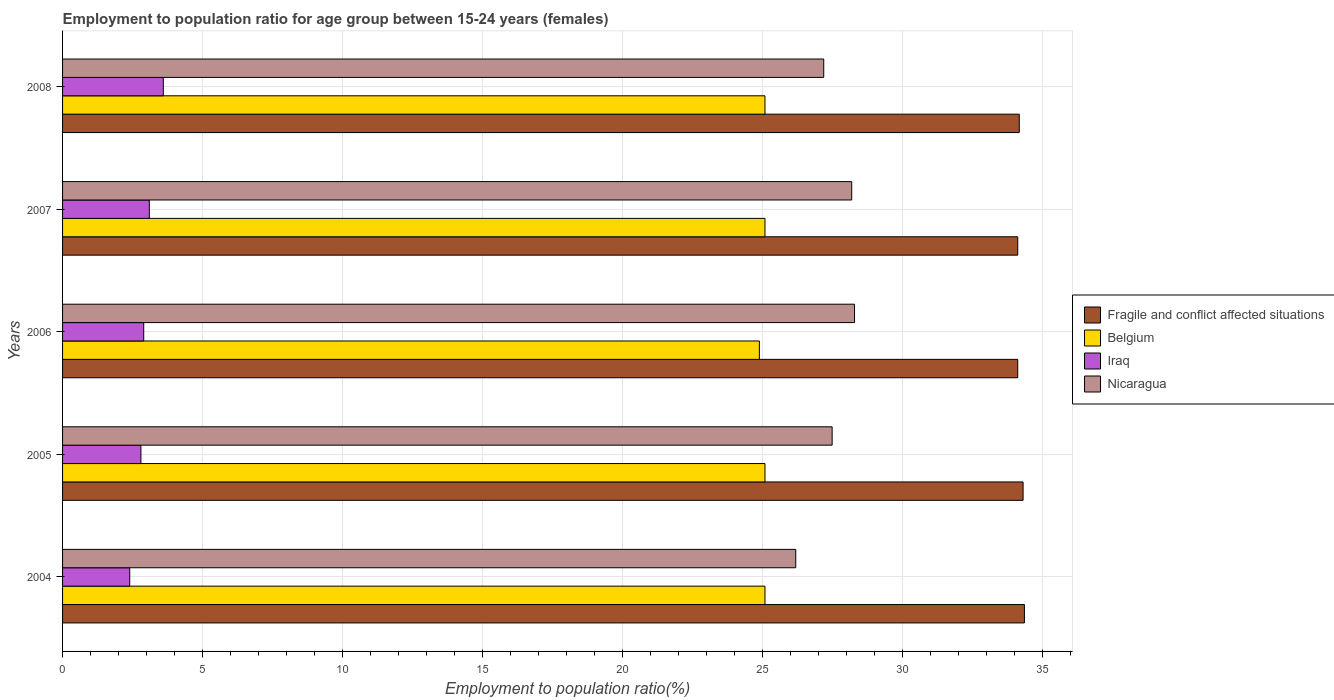Are the number of bars on each tick of the Y-axis equal?
Your answer should be very brief. Yes. How many bars are there on the 1st tick from the bottom?
Provide a short and direct response. 4. What is the label of the 1st group of bars from the top?
Provide a succinct answer. 2008. In how many cases, is the number of bars for a given year not equal to the number of legend labels?
Give a very brief answer. 0. What is the employment to population ratio in Iraq in 2007?
Ensure brevity in your answer.  3.1. Across all years, what is the maximum employment to population ratio in Nicaragua?
Your response must be concise. 28.3. Across all years, what is the minimum employment to population ratio in Belgium?
Provide a short and direct response. 24.9. In which year was the employment to population ratio in Iraq maximum?
Your answer should be very brief. 2008. What is the total employment to population ratio in Fragile and conflict affected situations in the graph?
Keep it short and to the point. 171.15. What is the difference between the employment to population ratio in Fragile and conflict affected situations in 2006 and the employment to population ratio in Iraq in 2005?
Your answer should be very brief. 31.33. What is the average employment to population ratio in Fragile and conflict affected situations per year?
Make the answer very short. 34.23. In the year 2008, what is the difference between the employment to population ratio in Belgium and employment to population ratio in Nicaragua?
Provide a short and direct response. -2.1. Is the employment to population ratio in Fragile and conflict affected situations in 2004 less than that in 2005?
Your answer should be very brief. No. What is the difference between the highest and the second highest employment to population ratio in Nicaragua?
Offer a very short reply. 0.1. What is the difference between the highest and the lowest employment to population ratio in Fragile and conflict affected situations?
Your answer should be very brief. 0.24. What does the 3rd bar from the bottom in 2006 represents?
Make the answer very short. Iraq. Are all the bars in the graph horizontal?
Ensure brevity in your answer.  Yes. What is the difference between two consecutive major ticks on the X-axis?
Offer a very short reply. 5. Are the values on the major ticks of X-axis written in scientific E-notation?
Ensure brevity in your answer.  No. How are the legend labels stacked?
Give a very brief answer. Vertical. What is the title of the graph?
Your response must be concise. Employment to population ratio for age group between 15-24 years (females). Does "Lesotho" appear as one of the legend labels in the graph?
Your response must be concise. No. What is the label or title of the X-axis?
Offer a terse response. Employment to population ratio(%). What is the Employment to population ratio(%) in Fragile and conflict affected situations in 2004?
Ensure brevity in your answer.  34.37. What is the Employment to population ratio(%) of Belgium in 2004?
Make the answer very short. 25.1. What is the Employment to population ratio(%) of Iraq in 2004?
Provide a short and direct response. 2.4. What is the Employment to population ratio(%) of Nicaragua in 2004?
Provide a succinct answer. 26.2. What is the Employment to population ratio(%) of Fragile and conflict affected situations in 2005?
Give a very brief answer. 34.32. What is the Employment to population ratio(%) in Belgium in 2005?
Ensure brevity in your answer.  25.1. What is the Employment to population ratio(%) in Iraq in 2005?
Keep it short and to the point. 2.8. What is the Employment to population ratio(%) of Nicaragua in 2005?
Ensure brevity in your answer.  27.5. What is the Employment to population ratio(%) of Fragile and conflict affected situations in 2006?
Keep it short and to the point. 34.13. What is the Employment to population ratio(%) of Belgium in 2006?
Offer a very short reply. 24.9. What is the Employment to population ratio(%) in Iraq in 2006?
Give a very brief answer. 2.9. What is the Employment to population ratio(%) of Nicaragua in 2006?
Provide a succinct answer. 28.3. What is the Employment to population ratio(%) of Fragile and conflict affected situations in 2007?
Provide a short and direct response. 34.13. What is the Employment to population ratio(%) of Belgium in 2007?
Give a very brief answer. 25.1. What is the Employment to population ratio(%) in Iraq in 2007?
Ensure brevity in your answer.  3.1. What is the Employment to population ratio(%) of Nicaragua in 2007?
Your answer should be very brief. 28.2. What is the Employment to population ratio(%) in Fragile and conflict affected situations in 2008?
Make the answer very short. 34.19. What is the Employment to population ratio(%) in Belgium in 2008?
Offer a very short reply. 25.1. What is the Employment to population ratio(%) of Iraq in 2008?
Give a very brief answer. 3.6. What is the Employment to population ratio(%) in Nicaragua in 2008?
Your answer should be compact. 27.2. Across all years, what is the maximum Employment to population ratio(%) in Fragile and conflict affected situations?
Give a very brief answer. 34.37. Across all years, what is the maximum Employment to population ratio(%) of Belgium?
Provide a short and direct response. 25.1. Across all years, what is the maximum Employment to population ratio(%) in Iraq?
Provide a succinct answer. 3.6. Across all years, what is the maximum Employment to population ratio(%) in Nicaragua?
Provide a succinct answer. 28.3. Across all years, what is the minimum Employment to population ratio(%) of Fragile and conflict affected situations?
Keep it short and to the point. 34.13. Across all years, what is the minimum Employment to population ratio(%) in Belgium?
Your response must be concise. 24.9. Across all years, what is the minimum Employment to population ratio(%) in Iraq?
Your answer should be compact. 2.4. Across all years, what is the minimum Employment to population ratio(%) of Nicaragua?
Your response must be concise. 26.2. What is the total Employment to population ratio(%) in Fragile and conflict affected situations in the graph?
Offer a terse response. 171.15. What is the total Employment to population ratio(%) of Belgium in the graph?
Offer a very short reply. 125.3. What is the total Employment to population ratio(%) in Iraq in the graph?
Offer a very short reply. 14.8. What is the total Employment to population ratio(%) in Nicaragua in the graph?
Offer a very short reply. 137.4. What is the difference between the Employment to population ratio(%) of Fragile and conflict affected situations in 2004 and that in 2005?
Offer a terse response. 0.05. What is the difference between the Employment to population ratio(%) of Iraq in 2004 and that in 2005?
Your answer should be compact. -0.4. What is the difference between the Employment to population ratio(%) in Fragile and conflict affected situations in 2004 and that in 2006?
Give a very brief answer. 0.24. What is the difference between the Employment to population ratio(%) in Iraq in 2004 and that in 2006?
Offer a very short reply. -0.5. What is the difference between the Employment to population ratio(%) in Nicaragua in 2004 and that in 2006?
Your response must be concise. -2.1. What is the difference between the Employment to population ratio(%) in Fragile and conflict affected situations in 2004 and that in 2007?
Keep it short and to the point. 0.24. What is the difference between the Employment to population ratio(%) in Nicaragua in 2004 and that in 2007?
Keep it short and to the point. -2. What is the difference between the Employment to population ratio(%) of Fragile and conflict affected situations in 2004 and that in 2008?
Offer a terse response. 0.18. What is the difference between the Employment to population ratio(%) of Belgium in 2004 and that in 2008?
Offer a very short reply. 0. What is the difference between the Employment to population ratio(%) in Iraq in 2004 and that in 2008?
Ensure brevity in your answer.  -1.2. What is the difference between the Employment to population ratio(%) of Fragile and conflict affected situations in 2005 and that in 2006?
Ensure brevity in your answer.  0.19. What is the difference between the Employment to population ratio(%) of Iraq in 2005 and that in 2006?
Your answer should be very brief. -0.1. What is the difference between the Employment to population ratio(%) in Fragile and conflict affected situations in 2005 and that in 2007?
Your response must be concise. 0.19. What is the difference between the Employment to population ratio(%) in Iraq in 2005 and that in 2007?
Provide a short and direct response. -0.3. What is the difference between the Employment to population ratio(%) in Fragile and conflict affected situations in 2005 and that in 2008?
Ensure brevity in your answer.  0.14. What is the difference between the Employment to population ratio(%) in Iraq in 2005 and that in 2008?
Offer a terse response. -0.8. What is the difference between the Employment to population ratio(%) in Nicaragua in 2005 and that in 2008?
Keep it short and to the point. 0.3. What is the difference between the Employment to population ratio(%) of Fragile and conflict affected situations in 2006 and that in 2007?
Make the answer very short. -0. What is the difference between the Employment to population ratio(%) of Fragile and conflict affected situations in 2006 and that in 2008?
Keep it short and to the point. -0.05. What is the difference between the Employment to population ratio(%) in Iraq in 2006 and that in 2008?
Offer a terse response. -0.7. What is the difference between the Employment to population ratio(%) in Nicaragua in 2006 and that in 2008?
Give a very brief answer. 1.1. What is the difference between the Employment to population ratio(%) of Fragile and conflict affected situations in 2007 and that in 2008?
Give a very brief answer. -0.05. What is the difference between the Employment to population ratio(%) in Belgium in 2007 and that in 2008?
Provide a succinct answer. 0. What is the difference between the Employment to population ratio(%) in Iraq in 2007 and that in 2008?
Offer a very short reply. -0.5. What is the difference between the Employment to population ratio(%) of Nicaragua in 2007 and that in 2008?
Your answer should be compact. 1. What is the difference between the Employment to population ratio(%) of Fragile and conflict affected situations in 2004 and the Employment to population ratio(%) of Belgium in 2005?
Provide a succinct answer. 9.27. What is the difference between the Employment to population ratio(%) of Fragile and conflict affected situations in 2004 and the Employment to population ratio(%) of Iraq in 2005?
Give a very brief answer. 31.57. What is the difference between the Employment to population ratio(%) of Fragile and conflict affected situations in 2004 and the Employment to population ratio(%) of Nicaragua in 2005?
Offer a terse response. 6.87. What is the difference between the Employment to population ratio(%) of Belgium in 2004 and the Employment to population ratio(%) of Iraq in 2005?
Make the answer very short. 22.3. What is the difference between the Employment to population ratio(%) of Belgium in 2004 and the Employment to population ratio(%) of Nicaragua in 2005?
Your answer should be very brief. -2.4. What is the difference between the Employment to population ratio(%) in Iraq in 2004 and the Employment to population ratio(%) in Nicaragua in 2005?
Keep it short and to the point. -25.1. What is the difference between the Employment to population ratio(%) in Fragile and conflict affected situations in 2004 and the Employment to population ratio(%) in Belgium in 2006?
Offer a very short reply. 9.47. What is the difference between the Employment to population ratio(%) in Fragile and conflict affected situations in 2004 and the Employment to population ratio(%) in Iraq in 2006?
Offer a very short reply. 31.47. What is the difference between the Employment to population ratio(%) of Fragile and conflict affected situations in 2004 and the Employment to population ratio(%) of Nicaragua in 2006?
Ensure brevity in your answer.  6.07. What is the difference between the Employment to population ratio(%) of Belgium in 2004 and the Employment to population ratio(%) of Iraq in 2006?
Give a very brief answer. 22.2. What is the difference between the Employment to population ratio(%) of Belgium in 2004 and the Employment to population ratio(%) of Nicaragua in 2006?
Make the answer very short. -3.2. What is the difference between the Employment to population ratio(%) of Iraq in 2004 and the Employment to population ratio(%) of Nicaragua in 2006?
Your response must be concise. -25.9. What is the difference between the Employment to population ratio(%) in Fragile and conflict affected situations in 2004 and the Employment to population ratio(%) in Belgium in 2007?
Make the answer very short. 9.27. What is the difference between the Employment to population ratio(%) in Fragile and conflict affected situations in 2004 and the Employment to population ratio(%) in Iraq in 2007?
Offer a terse response. 31.27. What is the difference between the Employment to population ratio(%) in Fragile and conflict affected situations in 2004 and the Employment to population ratio(%) in Nicaragua in 2007?
Offer a terse response. 6.17. What is the difference between the Employment to population ratio(%) of Belgium in 2004 and the Employment to population ratio(%) of Iraq in 2007?
Ensure brevity in your answer.  22. What is the difference between the Employment to population ratio(%) in Belgium in 2004 and the Employment to population ratio(%) in Nicaragua in 2007?
Offer a very short reply. -3.1. What is the difference between the Employment to population ratio(%) in Iraq in 2004 and the Employment to population ratio(%) in Nicaragua in 2007?
Offer a very short reply. -25.8. What is the difference between the Employment to population ratio(%) in Fragile and conflict affected situations in 2004 and the Employment to population ratio(%) in Belgium in 2008?
Provide a short and direct response. 9.27. What is the difference between the Employment to population ratio(%) in Fragile and conflict affected situations in 2004 and the Employment to population ratio(%) in Iraq in 2008?
Offer a terse response. 30.77. What is the difference between the Employment to population ratio(%) of Fragile and conflict affected situations in 2004 and the Employment to population ratio(%) of Nicaragua in 2008?
Provide a succinct answer. 7.17. What is the difference between the Employment to population ratio(%) of Belgium in 2004 and the Employment to population ratio(%) of Nicaragua in 2008?
Offer a very short reply. -2.1. What is the difference between the Employment to population ratio(%) of Iraq in 2004 and the Employment to population ratio(%) of Nicaragua in 2008?
Offer a very short reply. -24.8. What is the difference between the Employment to population ratio(%) of Fragile and conflict affected situations in 2005 and the Employment to population ratio(%) of Belgium in 2006?
Your response must be concise. 9.42. What is the difference between the Employment to population ratio(%) of Fragile and conflict affected situations in 2005 and the Employment to population ratio(%) of Iraq in 2006?
Your answer should be compact. 31.42. What is the difference between the Employment to population ratio(%) in Fragile and conflict affected situations in 2005 and the Employment to population ratio(%) in Nicaragua in 2006?
Provide a short and direct response. 6.02. What is the difference between the Employment to population ratio(%) of Belgium in 2005 and the Employment to population ratio(%) of Nicaragua in 2006?
Provide a short and direct response. -3.2. What is the difference between the Employment to population ratio(%) in Iraq in 2005 and the Employment to population ratio(%) in Nicaragua in 2006?
Provide a succinct answer. -25.5. What is the difference between the Employment to population ratio(%) of Fragile and conflict affected situations in 2005 and the Employment to population ratio(%) of Belgium in 2007?
Provide a succinct answer. 9.22. What is the difference between the Employment to population ratio(%) of Fragile and conflict affected situations in 2005 and the Employment to population ratio(%) of Iraq in 2007?
Your response must be concise. 31.22. What is the difference between the Employment to population ratio(%) of Fragile and conflict affected situations in 2005 and the Employment to population ratio(%) of Nicaragua in 2007?
Make the answer very short. 6.12. What is the difference between the Employment to population ratio(%) of Iraq in 2005 and the Employment to population ratio(%) of Nicaragua in 2007?
Your answer should be compact. -25.4. What is the difference between the Employment to population ratio(%) in Fragile and conflict affected situations in 2005 and the Employment to population ratio(%) in Belgium in 2008?
Your response must be concise. 9.22. What is the difference between the Employment to population ratio(%) of Fragile and conflict affected situations in 2005 and the Employment to population ratio(%) of Iraq in 2008?
Give a very brief answer. 30.72. What is the difference between the Employment to population ratio(%) of Fragile and conflict affected situations in 2005 and the Employment to population ratio(%) of Nicaragua in 2008?
Offer a terse response. 7.12. What is the difference between the Employment to population ratio(%) of Belgium in 2005 and the Employment to population ratio(%) of Iraq in 2008?
Your response must be concise. 21.5. What is the difference between the Employment to population ratio(%) of Iraq in 2005 and the Employment to population ratio(%) of Nicaragua in 2008?
Keep it short and to the point. -24.4. What is the difference between the Employment to population ratio(%) of Fragile and conflict affected situations in 2006 and the Employment to population ratio(%) of Belgium in 2007?
Your answer should be compact. 9.03. What is the difference between the Employment to population ratio(%) in Fragile and conflict affected situations in 2006 and the Employment to population ratio(%) in Iraq in 2007?
Give a very brief answer. 31.03. What is the difference between the Employment to population ratio(%) in Fragile and conflict affected situations in 2006 and the Employment to population ratio(%) in Nicaragua in 2007?
Provide a short and direct response. 5.93. What is the difference between the Employment to population ratio(%) of Belgium in 2006 and the Employment to population ratio(%) of Iraq in 2007?
Provide a succinct answer. 21.8. What is the difference between the Employment to population ratio(%) of Belgium in 2006 and the Employment to population ratio(%) of Nicaragua in 2007?
Offer a very short reply. -3.3. What is the difference between the Employment to population ratio(%) of Iraq in 2006 and the Employment to population ratio(%) of Nicaragua in 2007?
Your response must be concise. -25.3. What is the difference between the Employment to population ratio(%) of Fragile and conflict affected situations in 2006 and the Employment to population ratio(%) of Belgium in 2008?
Your response must be concise. 9.03. What is the difference between the Employment to population ratio(%) of Fragile and conflict affected situations in 2006 and the Employment to population ratio(%) of Iraq in 2008?
Provide a succinct answer. 30.53. What is the difference between the Employment to population ratio(%) of Fragile and conflict affected situations in 2006 and the Employment to population ratio(%) of Nicaragua in 2008?
Keep it short and to the point. 6.93. What is the difference between the Employment to population ratio(%) in Belgium in 2006 and the Employment to population ratio(%) in Iraq in 2008?
Give a very brief answer. 21.3. What is the difference between the Employment to population ratio(%) of Belgium in 2006 and the Employment to population ratio(%) of Nicaragua in 2008?
Give a very brief answer. -2.3. What is the difference between the Employment to population ratio(%) in Iraq in 2006 and the Employment to population ratio(%) in Nicaragua in 2008?
Offer a terse response. -24.3. What is the difference between the Employment to population ratio(%) of Fragile and conflict affected situations in 2007 and the Employment to population ratio(%) of Belgium in 2008?
Your answer should be compact. 9.03. What is the difference between the Employment to population ratio(%) of Fragile and conflict affected situations in 2007 and the Employment to population ratio(%) of Iraq in 2008?
Keep it short and to the point. 30.53. What is the difference between the Employment to population ratio(%) of Fragile and conflict affected situations in 2007 and the Employment to population ratio(%) of Nicaragua in 2008?
Keep it short and to the point. 6.93. What is the difference between the Employment to population ratio(%) in Belgium in 2007 and the Employment to population ratio(%) in Iraq in 2008?
Give a very brief answer. 21.5. What is the difference between the Employment to population ratio(%) of Belgium in 2007 and the Employment to population ratio(%) of Nicaragua in 2008?
Make the answer very short. -2.1. What is the difference between the Employment to population ratio(%) of Iraq in 2007 and the Employment to population ratio(%) of Nicaragua in 2008?
Offer a very short reply. -24.1. What is the average Employment to population ratio(%) of Fragile and conflict affected situations per year?
Make the answer very short. 34.23. What is the average Employment to population ratio(%) of Belgium per year?
Make the answer very short. 25.06. What is the average Employment to population ratio(%) in Iraq per year?
Keep it short and to the point. 2.96. What is the average Employment to population ratio(%) of Nicaragua per year?
Make the answer very short. 27.48. In the year 2004, what is the difference between the Employment to population ratio(%) in Fragile and conflict affected situations and Employment to population ratio(%) in Belgium?
Offer a very short reply. 9.27. In the year 2004, what is the difference between the Employment to population ratio(%) in Fragile and conflict affected situations and Employment to population ratio(%) in Iraq?
Your answer should be very brief. 31.97. In the year 2004, what is the difference between the Employment to population ratio(%) in Fragile and conflict affected situations and Employment to population ratio(%) in Nicaragua?
Ensure brevity in your answer.  8.17. In the year 2004, what is the difference between the Employment to population ratio(%) of Belgium and Employment to population ratio(%) of Iraq?
Your answer should be compact. 22.7. In the year 2004, what is the difference between the Employment to population ratio(%) of Belgium and Employment to population ratio(%) of Nicaragua?
Give a very brief answer. -1.1. In the year 2004, what is the difference between the Employment to population ratio(%) in Iraq and Employment to population ratio(%) in Nicaragua?
Your response must be concise. -23.8. In the year 2005, what is the difference between the Employment to population ratio(%) in Fragile and conflict affected situations and Employment to population ratio(%) in Belgium?
Offer a terse response. 9.22. In the year 2005, what is the difference between the Employment to population ratio(%) of Fragile and conflict affected situations and Employment to population ratio(%) of Iraq?
Your response must be concise. 31.52. In the year 2005, what is the difference between the Employment to population ratio(%) of Fragile and conflict affected situations and Employment to population ratio(%) of Nicaragua?
Provide a short and direct response. 6.82. In the year 2005, what is the difference between the Employment to population ratio(%) of Belgium and Employment to population ratio(%) of Iraq?
Keep it short and to the point. 22.3. In the year 2005, what is the difference between the Employment to population ratio(%) in Belgium and Employment to population ratio(%) in Nicaragua?
Offer a terse response. -2.4. In the year 2005, what is the difference between the Employment to population ratio(%) of Iraq and Employment to population ratio(%) of Nicaragua?
Your response must be concise. -24.7. In the year 2006, what is the difference between the Employment to population ratio(%) in Fragile and conflict affected situations and Employment to population ratio(%) in Belgium?
Offer a very short reply. 9.23. In the year 2006, what is the difference between the Employment to population ratio(%) of Fragile and conflict affected situations and Employment to population ratio(%) of Iraq?
Ensure brevity in your answer.  31.23. In the year 2006, what is the difference between the Employment to population ratio(%) in Fragile and conflict affected situations and Employment to population ratio(%) in Nicaragua?
Give a very brief answer. 5.83. In the year 2006, what is the difference between the Employment to population ratio(%) in Belgium and Employment to population ratio(%) in Iraq?
Offer a terse response. 22. In the year 2006, what is the difference between the Employment to population ratio(%) in Iraq and Employment to population ratio(%) in Nicaragua?
Offer a terse response. -25.4. In the year 2007, what is the difference between the Employment to population ratio(%) in Fragile and conflict affected situations and Employment to population ratio(%) in Belgium?
Make the answer very short. 9.03. In the year 2007, what is the difference between the Employment to population ratio(%) in Fragile and conflict affected situations and Employment to population ratio(%) in Iraq?
Keep it short and to the point. 31.03. In the year 2007, what is the difference between the Employment to population ratio(%) of Fragile and conflict affected situations and Employment to population ratio(%) of Nicaragua?
Offer a terse response. 5.93. In the year 2007, what is the difference between the Employment to population ratio(%) in Belgium and Employment to population ratio(%) in Iraq?
Provide a short and direct response. 22. In the year 2007, what is the difference between the Employment to population ratio(%) of Iraq and Employment to population ratio(%) of Nicaragua?
Provide a succinct answer. -25.1. In the year 2008, what is the difference between the Employment to population ratio(%) in Fragile and conflict affected situations and Employment to population ratio(%) in Belgium?
Your answer should be very brief. 9.09. In the year 2008, what is the difference between the Employment to population ratio(%) in Fragile and conflict affected situations and Employment to population ratio(%) in Iraq?
Offer a terse response. 30.59. In the year 2008, what is the difference between the Employment to population ratio(%) of Fragile and conflict affected situations and Employment to population ratio(%) of Nicaragua?
Your answer should be compact. 6.99. In the year 2008, what is the difference between the Employment to population ratio(%) of Belgium and Employment to population ratio(%) of Iraq?
Give a very brief answer. 21.5. In the year 2008, what is the difference between the Employment to population ratio(%) of Belgium and Employment to population ratio(%) of Nicaragua?
Offer a terse response. -2.1. In the year 2008, what is the difference between the Employment to population ratio(%) in Iraq and Employment to population ratio(%) in Nicaragua?
Ensure brevity in your answer.  -23.6. What is the ratio of the Employment to population ratio(%) in Nicaragua in 2004 to that in 2005?
Keep it short and to the point. 0.95. What is the ratio of the Employment to population ratio(%) of Fragile and conflict affected situations in 2004 to that in 2006?
Provide a succinct answer. 1.01. What is the ratio of the Employment to population ratio(%) in Belgium in 2004 to that in 2006?
Make the answer very short. 1.01. What is the ratio of the Employment to population ratio(%) of Iraq in 2004 to that in 2006?
Keep it short and to the point. 0.83. What is the ratio of the Employment to population ratio(%) of Nicaragua in 2004 to that in 2006?
Give a very brief answer. 0.93. What is the ratio of the Employment to population ratio(%) in Belgium in 2004 to that in 2007?
Keep it short and to the point. 1. What is the ratio of the Employment to population ratio(%) of Iraq in 2004 to that in 2007?
Your answer should be compact. 0.77. What is the ratio of the Employment to population ratio(%) in Nicaragua in 2004 to that in 2007?
Provide a short and direct response. 0.93. What is the ratio of the Employment to population ratio(%) in Fragile and conflict affected situations in 2004 to that in 2008?
Give a very brief answer. 1.01. What is the ratio of the Employment to population ratio(%) in Belgium in 2004 to that in 2008?
Your response must be concise. 1. What is the ratio of the Employment to population ratio(%) in Nicaragua in 2004 to that in 2008?
Your answer should be compact. 0.96. What is the ratio of the Employment to population ratio(%) of Fragile and conflict affected situations in 2005 to that in 2006?
Provide a short and direct response. 1.01. What is the ratio of the Employment to population ratio(%) in Iraq in 2005 to that in 2006?
Provide a short and direct response. 0.97. What is the ratio of the Employment to population ratio(%) in Nicaragua in 2005 to that in 2006?
Your answer should be compact. 0.97. What is the ratio of the Employment to population ratio(%) in Fragile and conflict affected situations in 2005 to that in 2007?
Ensure brevity in your answer.  1.01. What is the ratio of the Employment to population ratio(%) of Iraq in 2005 to that in 2007?
Your answer should be very brief. 0.9. What is the ratio of the Employment to population ratio(%) of Nicaragua in 2005 to that in 2007?
Make the answer very short. 0.98. What is the ratio of the Employment to population ratio(%) of Fragile and conflict affected situations in 2006 to that in 2007?
Offer a very short reply. 1. What is the ratio of the Employment to population ratio(%) in Iraq in 2006 to that in 2007?
Your answer should be very brief. 0.94. What is the ratio of the Employment to population ratio(%) in Nicaragua in 2006 to that in 2007?
Your response must be concise. 1. What is the ratio of the Employment to population ratio(%) in Fragile and conflict affected situations in 2006 to that in 2008?
Offer a terse response. 1. What is the ratio of the Employment to population ratio(%) of Belgium in 2006 to that in 2008?
Keep it short and to the point. 0.99. What is the ratio of the Employment to population ratio(%) of Iraq in 2006 to that in 2008?
Provide a succinct answer. 0.81. What is the ratio of the Employment to population ratio(%) in Nicaragua in 2006 to that in 2008?
Your response must be concise. 1.04. What is the ratio of the Employment to population ratio(%) of Iraq in 2007 to that in 2008?
Your answer should be very brief. 0.86. What is the ratio of the Employment to population ratio(%) in Nicaragua in 2007 to that in 2008?
Your response must be concise. 1.04. What is the difference between the highest and the second highest Employment to population ratio(%) in Fragile and conflict affected situations?
Your answer should be very brief. 0.05. What is the difference between the highest and the second highest Employment to population ratio(%) of Nicaragua?
Your answer should be very brief. 0.1. What is the difference between the highest and the lowest Employment to population ratio(%) of Fragile and conflict affected situations?
Keep it short and to the point. 0.24. What is the difference between the highest and the lowest Employment to population ratio(%) in Iraq?
Provide a short and direct response. 1.2. What is the difference between the highest and the lowest Employment to population ratio(%) in Nicaragua?
Provide a succinct answer. 2.1. 